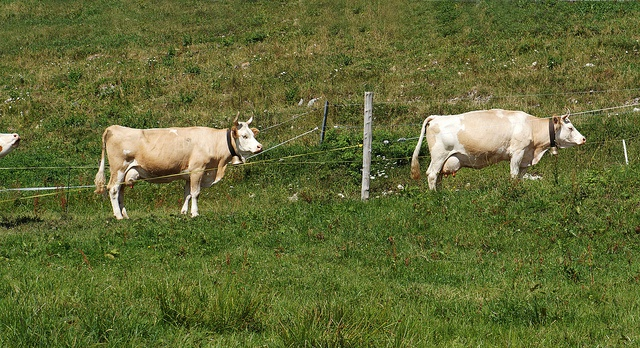Describe the objects in this image and their specific colors. I can see cow in darkgreen, tan, and ivory tones, cow in darkgreen, ivory, tan, and olive tones, and cow in darkgreen, ivory, black, and gray tones in this image. 